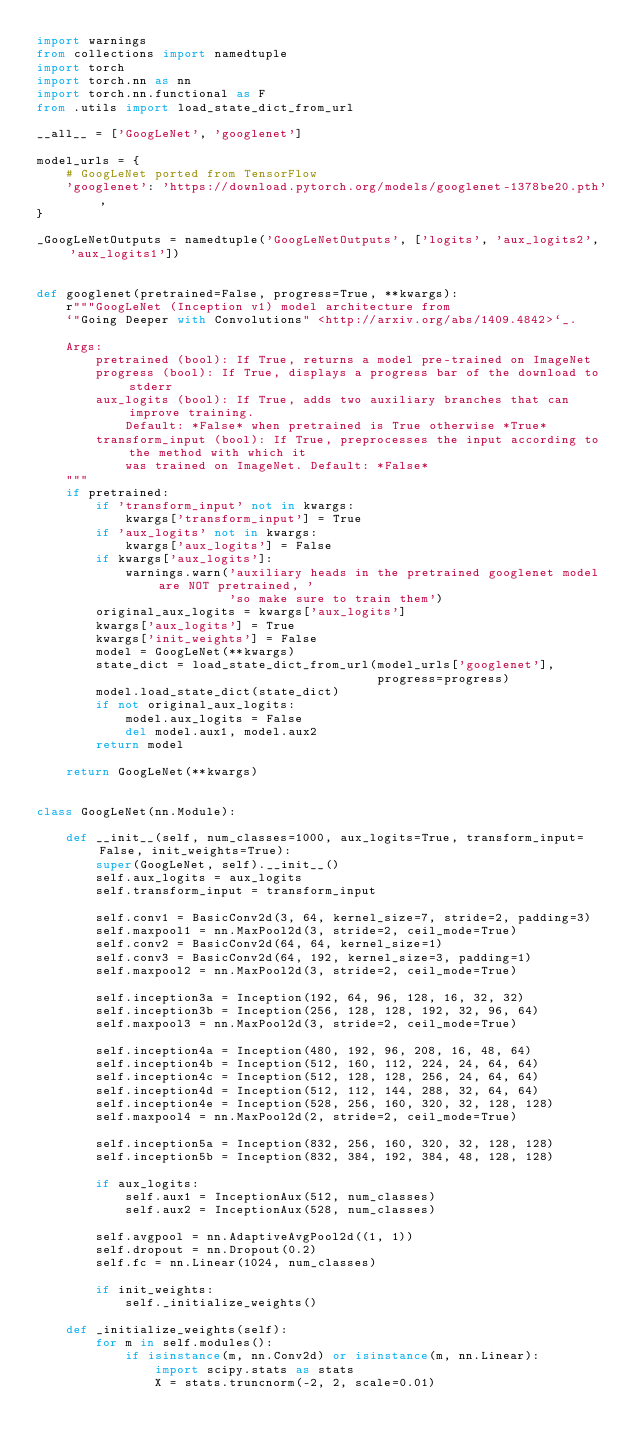<code> <loc_0><loc_0><loc_500><loc_500><_Python_>import warnings
from collections import namedtuple
import torch
import torch.nn as nn
import torch.nn.functional as F
from .utils import load_state_dict_from_url

__all__ = ['GoogLeNet', 'googlenet']

model_urls = {
    # GoogLeNet ported from TensorFlow
    'googlenet': 'https://download.pytorch.org/models/googlenet-1378be20.pth',
}

_GoogLeNetOutputs = namedtuple('GoogLeNetOutputs', ['logits', 'aux_logits2', 'aux_logits1'])


def googlenet(pretrained=False, progress=True, **kwargs):
    r"""GoogLeNet (Inception v1) model architecture from
    `"Going Deeper with Convolutions" <http://arxiv.org/abs/1409.4842>`_.

    Args:
        pretrained (bool): If True, returns a model pre-trained on ImageNet
        progress (bool): If True, displays a progress bar of the download to stderr
        aux_logits (bool): If True, adds two auxiliary branches that can improve training.
            Default: *False* when pretrained is True otherwise *True*
        transform_input (bool): If True, preprocesses the input according to the method with which it
            was trained on ImageNet. Default: *False*
    """
    if pretrained:
        if 'transform_input' not in kwargs:
            kwargs['transform_input'] = True
        if 'aux_logits' not in kwargs:
            kwargs['aux_logits'] = False
        if kwargs['aux_logits']:
            warnings.warn('auxiliary heads in the pretrained googlenet model are NOT pretrained, '
                          'so make sure to train them')
        original_aux_logits = kwargs['aux_logits']
        kwargs['aux_logits'] = True
        kwargs['init_weights'] = False
        model = GoogLeNet(**kwargs)
        state_dict = load_state_dict_from_url(model_urls['googlenet'],
                                              progress=progress)
        model.load_state_dict(state_dict)
        if not original_aux_logits:
            model.aux_logits = False
            del model.aux1, model.aux2
        return model

    return GoogLeNet(**kwargs)


class GoogLeNet(nn.Module):

    def __init__(self, num_classes=1000, aux_logits=True, transform_input=False, init_weights=True):
        super(GoogLeNet, self).__init__()
        self.aux_logits = aux_logits
        self.transform_input = transform_input

        self.conv1 = BasicConv2d(3, 64, kernel_size=7, stride=2, padding=3)
        self.maxpool1 = nn.MaxPool2d(3, stride=2, ceil_mode=True)
        self.conv2 = BasicConv2d(64, 64, kernel_size=1)
        self.conv3 = BasicConv2d(64, 192, kernel_size=3, padding=1)
        self.maxpool2 = nn.MaxPool2d(3, stride=2, ceil_mode=True)

        self.inception3a = Inception(192, 64, 96, 128, 16, 32, 32)
        self.inception3b = Inception(256, 128, 128, 192, 32, 96, 64)
        self.maxpool3 = nn.MaxPool2d(3, stride=2, ceil_mode=True)

        self.inception4a = Inception(480, 192, 96, 208, 16, 48, 64)
        self.inception4b = Inception(512, 160, 112, 224, 24, 64, 64)
        self.inception4c = Inception(512, 128, 128, 256, 24, 64, 64)
        self.inception4d = Inception(512, 112, 144, 288, 32, 64, 64)
        self.inception4e = Inception(528, 256, 160, 320, 32, 128, 128)
        self.maxpool4 = nn.MaxPool2d(2, stride=2, ceil_mode=True)

        self.inception5a = Inception(832, 256, 160, 320, 32, 128, 128)
        self.inception5b = Inception(832, 384, 192, 384, 48, 128, 128)

        if aux_logits:
            self.aux1 = InceptionAux(512, num_classes)
            self.aux2 = InceptionAux(528, num_classes)

        self.avgpool = nn.AdaptiveAvgPool2d((1, 1))
        self.dropout = nn.Dropout(0.2)
        self.fc = nn.Linear(1024, num_classes)

        if init_weights:
            self._initialize_weights()

    def _initialize_weights(self):
        for m in self.modules():
            if isinstance(m, nn.Conv2d) or isinstance(m, nn.Linear):
                import scipy.stats as stats
                X = stats.truncnorm(-2, 2, scale=0.01)</code> 